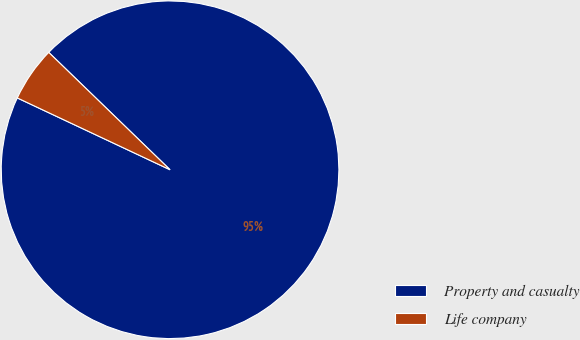Convert chart to OTSL. <chart><loc_0><loc_0><loc_500><loc_500><pie_chart><fcel>Property and casualty<fcel>Life company<nl><fcel>94.76%<fcel>5.24%<nl></chart> 